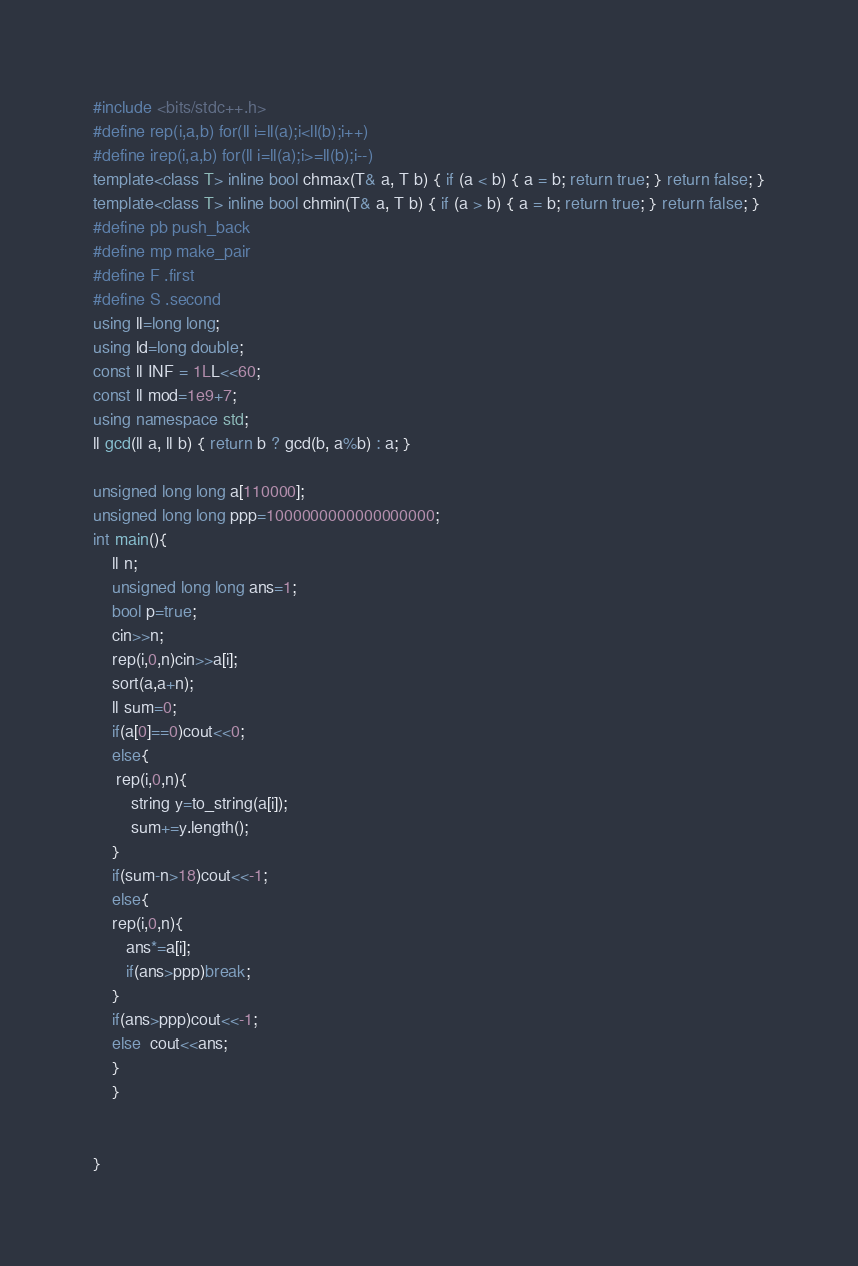Convert code to text. <code><loc_0><loc_0><loc_500><loc_500><_C++_>#include <bits/stdc++.h>
#define rep(i,a,b) for(ll i=ll(a);i<ll(b);i++)
#define irep(i,a,b) for(ll i=ll(a);i>=ll(b);i--)
template<class T> inline bool chmax(T& a, T b) { if (a < b) { a = b; return true; } return false; }
template<class T> inline bool chmin(T& a, T b) { if (a > b) { a = b; return true; } return false; }
#define pb push_back
#define mp make_pair
#define F .first
#define S .second 
using ll=long long;
using ld=long double;
const ll INF = 1LL<<60;
const ll mod=1e9+7;
using namespace std;
ll gcd(ll a, ll b) { return b ? gcd(b, a%b) : a; }

unsigned long long a[110000];
unsigned long long ppp=1000000000000000000;
int main(){
    ll n;
    unsigned long long ans=1;
    bool p=true;
    cin>>n;
    rep(i,0,n)cin>>a[i];
    sort(a,a+n);
    ll sum=0;
    if(a[0]==0)cout<<0;
    else{
     rep(i,0,n){
        string y=to_string(a[i]);
        sum+=y.length();
    }
    if(sum-n>18)cout<<-1;
    else{
    rep(i,0,n){
       ans*=a[i];
       if(ans>ppp)break;
    }
    if(ans>ppp)cout<<-1;
    else  cout<<ans;
    }
    }
    
   
}
</code> 